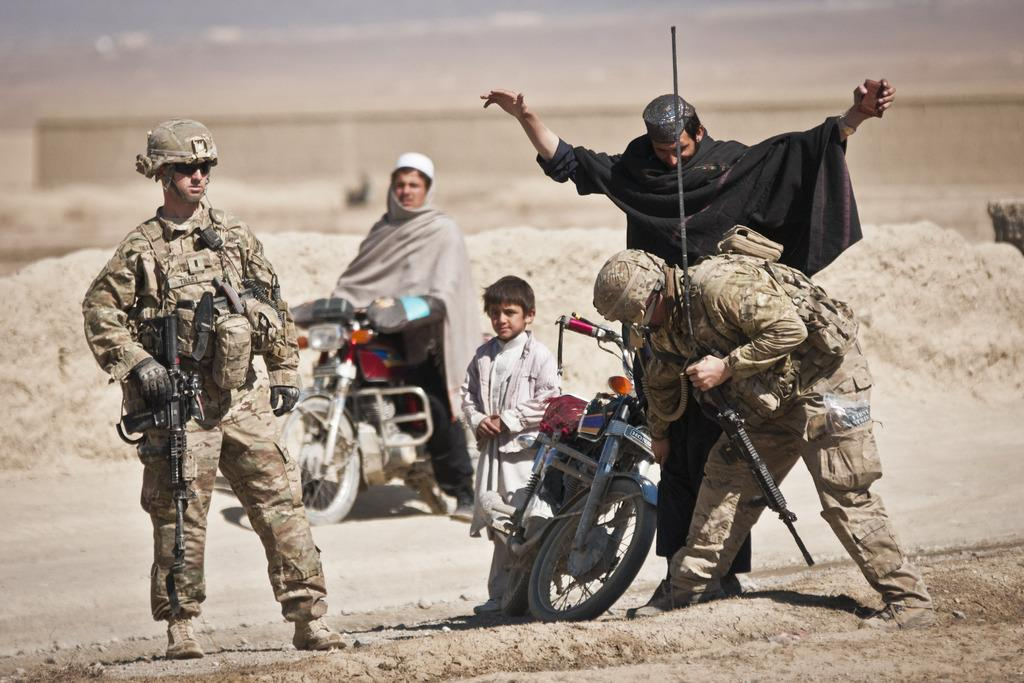What is the man on the left side of the image doing? The man on the left side of the image is catching a weapon. What can be seen in the middle of the image? There is a boy and a bike in the middle of the image, with a man sitting on the bike. How many persons are on the right side of the image? There are two persons on the right side of the image. What type of suit is the boy wearing while reading on the dock in the image? There is no dock, reading, or suit present in the image. The boy is in the middle of the image, and there is no mention of him reading or wearing a suit. 